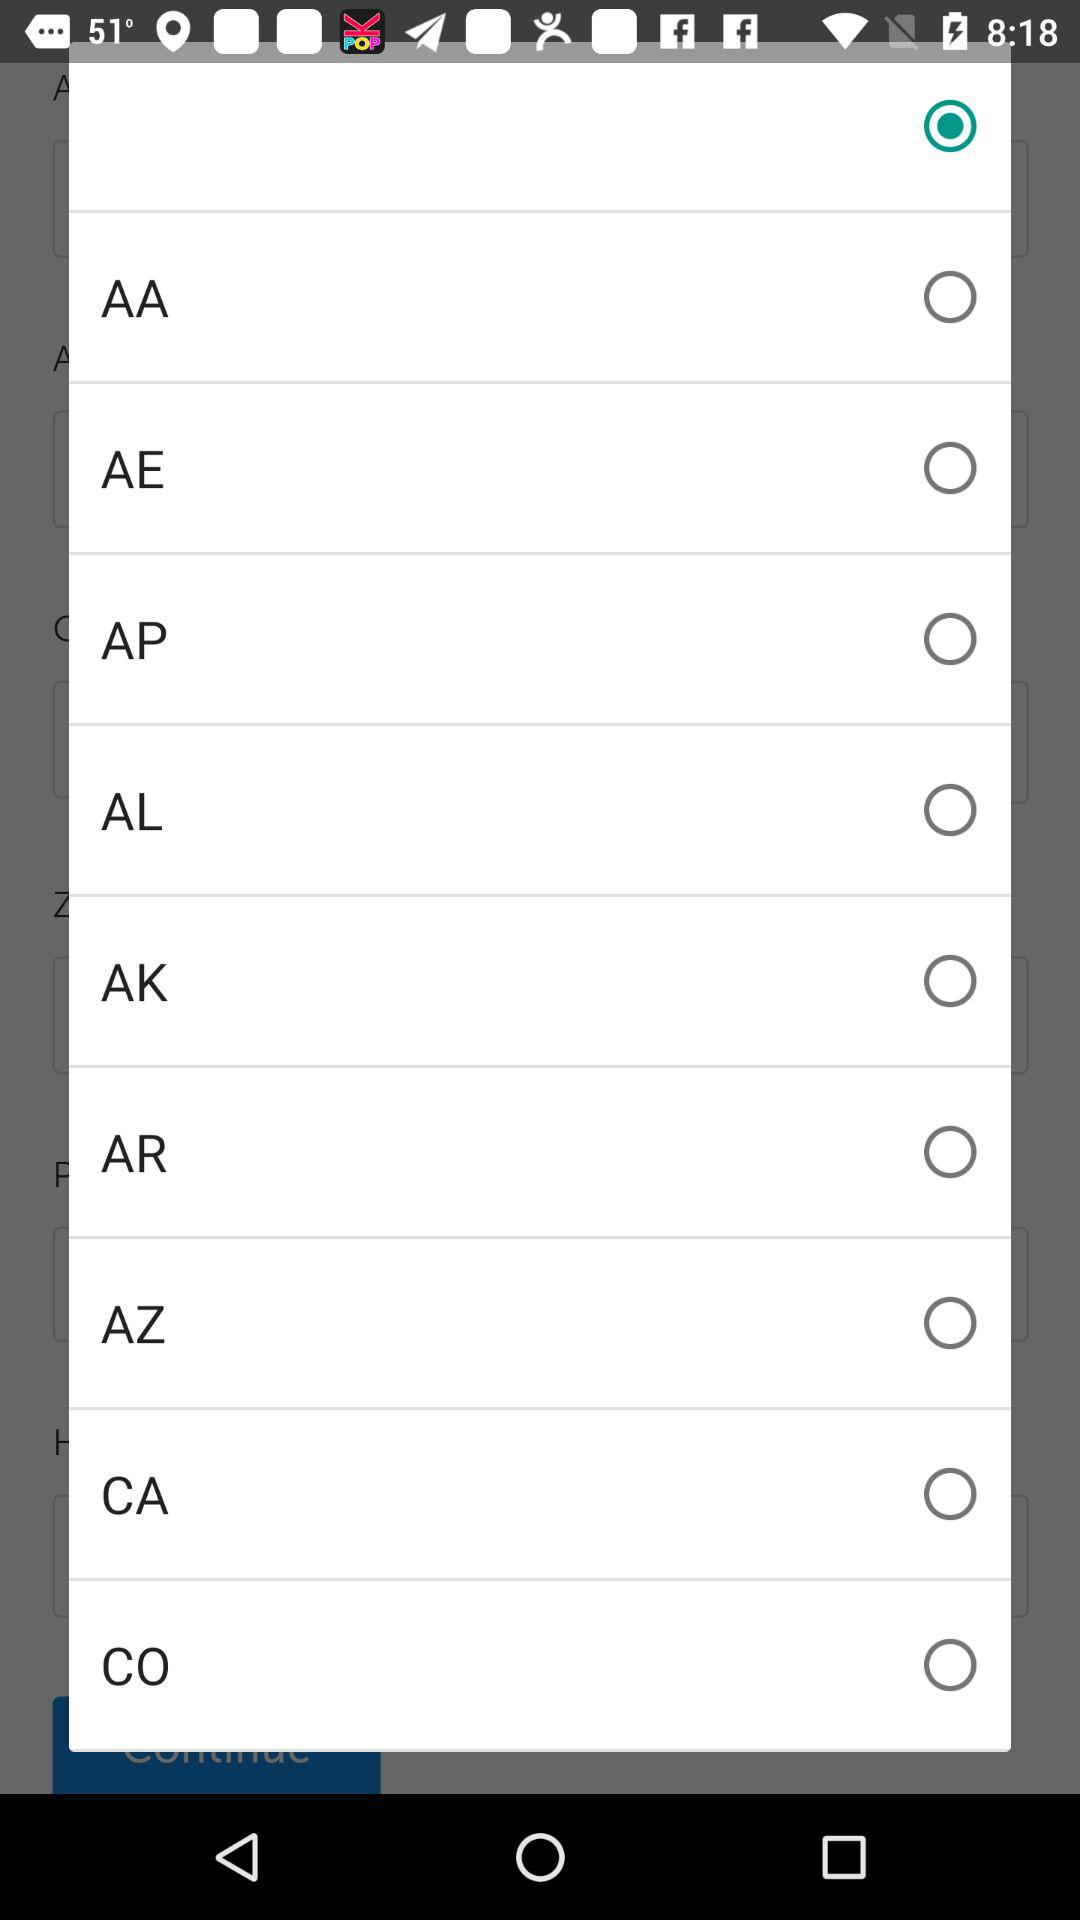Which option is selected?
When the provided information is insufficient, respond with <no answer>. <no answer> 